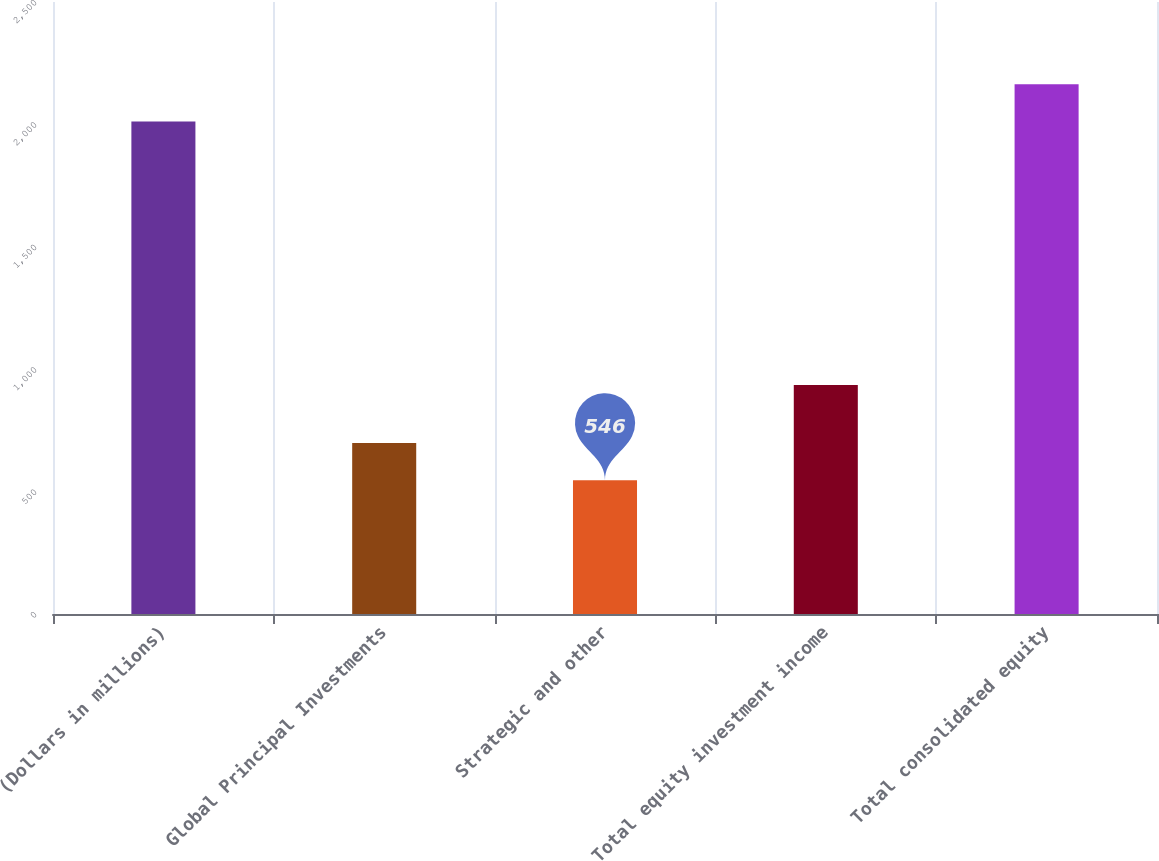Convert chart. <chart><loc_0><loc_0><loc_500><loc_500><bar_chart><fcel>(Dollars in millions)<fcel>Global Principal Investments<fcel>Strategic and other<fcel>Total equity investment income<fcel>Total consolidated equity<nl><fcel>2012<fcel>698.4<fcel>546<fcel>935<fcel>2164.4<nl></chart> 